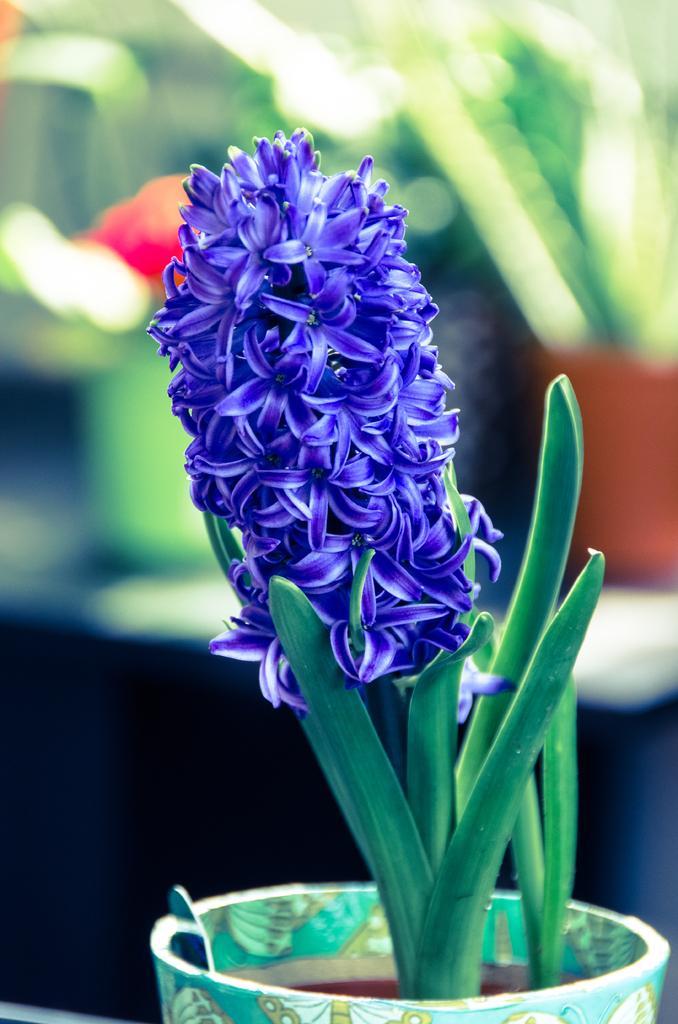Please provide a concise description of this image. This is a zoomed in picture. In the foreground we can see the flowers and a plant in the pot. The background of the image is blurry and green in color. 